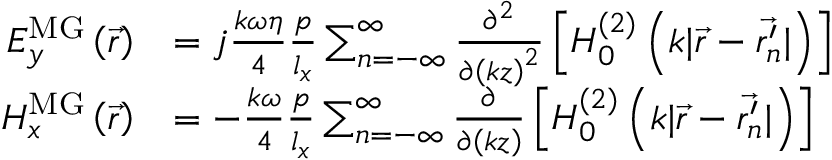Convert formula to latex. <formula><loc_0><loc_0><loc_500><loc_500>\begin{array} { r l } { E _ { y } ^ { M G } \left ( \vec { r } \right ) } & { = j \frac { k \omega \eta } { 4 } \frac { p } { l _ { x } } \sum _ { n = - \infty } ^ { \infty } \frac { \partial ^ { 2 } } { \partial \left ( k z \right ) ^ { 2 } } \left [ H _ { 0 } ^ { ( 2 ) } \left ( k | \vec { r } - \vec { r _ { n } ^ { \prime } } | \right ) \right ] } \\ { H _ { x } ^ { M G } \left ( \vec { r } \right ) } & { = - \frac { k \omega } { 4 } \frac { p } { l _ { x } } \sum _ { n = - \infty } ^ { \infty } \frac { \partial } { \partial \left ( k z \right ) } \left [ H _ { 0 } ^ { ( 2 ) } \left ( k | \vec { r } - \vec { r _ { n } ^ { \prime } } | \right ) \right ] } \end{array}</formula> 